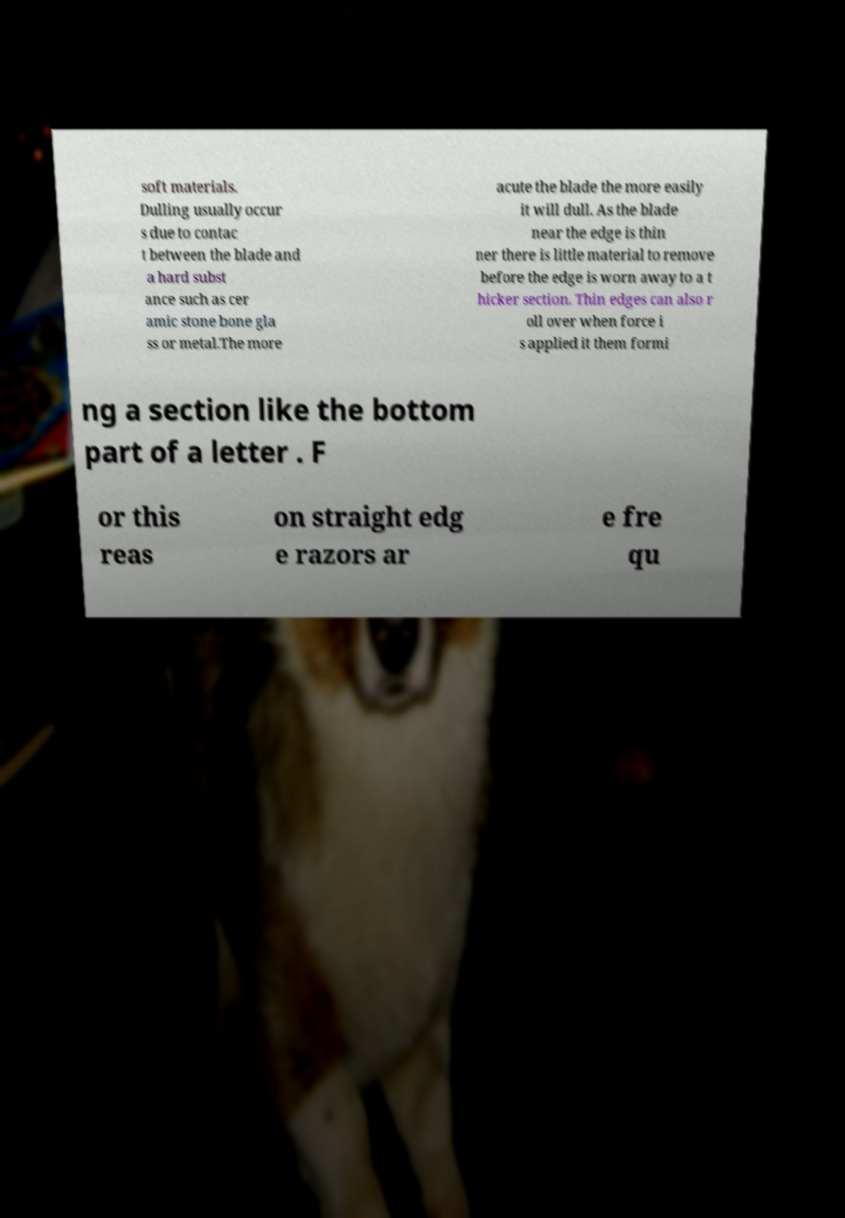Could you assist in decoding the text presented in this image and type it out clearly? soft materials. Dulling usually occur s due to contac t between the blade and a hard subst ance such as cer amic stone bone gla ss or metal.The more acute the blade the more easily it will dull. As the blade near the edge is thin ner there is little material to remove before the edge is worn away to a t hicker section. Thin edges can also r oll over when force i s applied it them formi ng a section like the bottom part of a letter . F or this reas on straight edg e razors ar e fre qu 